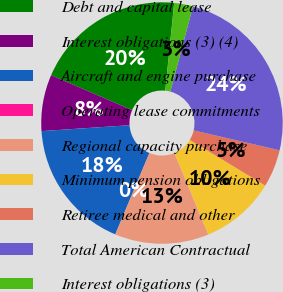Convert chart. <chart><loc_0><loc_0><loc_500><loc_500><pie_chart><fcel>Debt and capital lease<fcel>Interest obligations (3) (4)<fcel>Aircraft and engine purchase<fcel>Operating lease commitments<fcel>Regional capacity purchase<fcel>Minimum pension obligations<fcel>Retiree medical and other<fcel>Total American Contractual<fcel>Interest obligations (3)<nl><fcel>20.13%<fcel>7.55%<fcel>17.61%<fcel>0.01%<fcel>12.58%<fcel>10.07%<fcel>5.04%<fcel>24.49%<fcel>2.52%<nl></chart> 